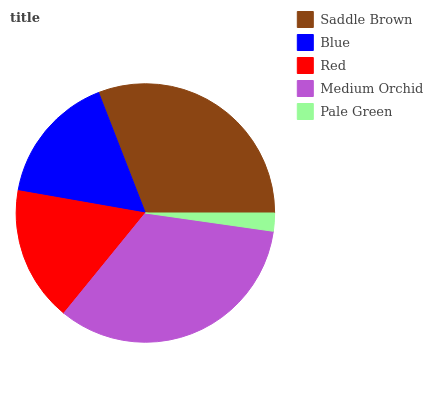Is Pale Green the minimum?
Answer yes or no. Yes. Is Medium Orchid the maximum?
Answer yes or no. Yes. Is Blue the minimum?
Answer yes or no. No. Is Blue the maximum?
Answer yes or no. No. Is Saddle Brown greater than Blue?
Answer yes or no. Yes. Is Blue less than Saddle Brown?
Answer yes or no. Yes. Is Blue greater than Saddle Brown?
Answer yes or no. No. Is Saddle Brown less than Blue?
Answer yes or no. No. Is Red the high median?
Answer yes or no. Yes. Is Red the low median?
Answer yes or no. Yes. Is Blue the high median?
Answer yes or no. No. Is Saddle Brown the low median?
Answer yes or no. No. 